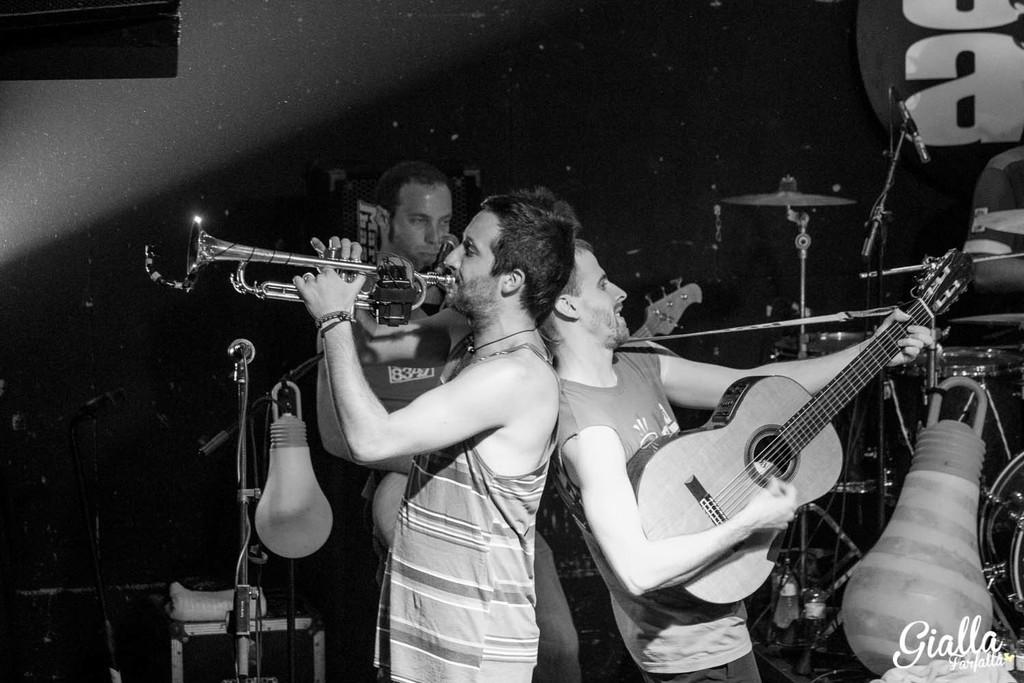How many people are in the image? There are people in the image, but the exact number is not specified. What are the people doing in the image? The people are standing and playing musical instruments. Can you describe the actions of the people in the image? The people are standing and using their hands to play musical instruments. What type of spring can be seen in the image? There is no spring present in the image. Who is the creator of the musical instruments being played in the image? The facts provided do not mention the creator of the musical instruments. 